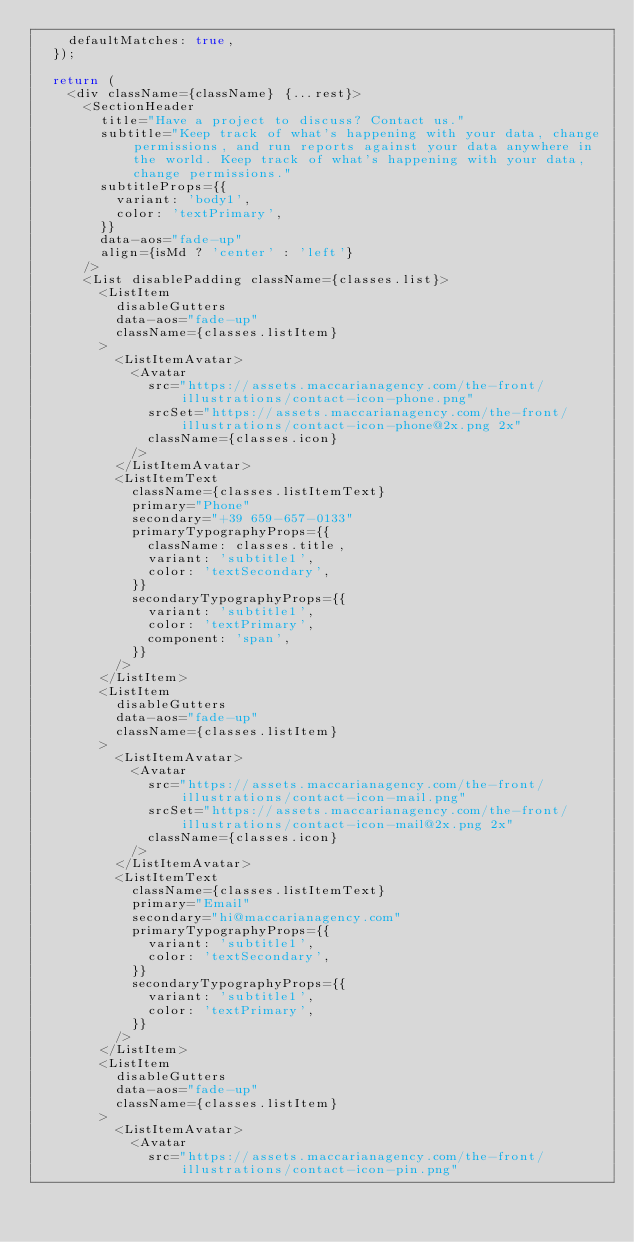<code> <loc_0><loc_0><loc_500><loc_500><_JavaScript_>    defaultMatches: true,
  });

  return (
    <div className={className} {...rest}>
      <SectionHeader
        title="Have a project to discuss? Contact us."
        subtitle="Keep track of what's happening with your data, change permissions, and run reports against your data anywhere in the world. Keep track of what's happening with your data, change permissions."
        subtitleProps={{
          variant: 'body1',
          color: 'textPrimary',
        }}
        data-aos="fade-up"
        align={isMd ? 'center' : 'left'}
      />
      <List disablePadding className={classes.list}>
        <ListItem
          disableGutters
          data-aos="fade-up"
          className={classes.listItem}
        >
          <ListItemAvatar>
            <Avatar
              src="https://assets.maccarianagency.com/the-front/illustrations/contact-icon-phone.png"
              srcSet="https://assets.maccarianagency.com/the-front/illustrations/contact-icon-phone@2x.png 2x"
              className={classes.icon}
            />
          </ListItemAvatar>
          <ListItemText
            className={classes.listItemText}
            primary="Phone"
            secondary="+39 659-657-0133"
            primaryTypographyProps={{
              className: classes.title,
              variant: 'subtitle1',
              color: 'textSecondary',
            }}
            secondaryTypographyProps={{
              variant: 'subtitle1',
              color: 'textPrimary',
              component: 'span',
            }}
          />
        </ListItem>
        <ListItem
          disableGutters
          data-aos="fade-up"
          className={classes.listItem}
        >
          <ListItemAvatar>
            <Avatar
              src="https://assets.maccarianagency.com/the-front/illustrations/contact-icon-mail.png"
              srcSet="https://assets.maccarianagency.com/the-front/illustrations/contact-icon-mail@2x.png 2x"
              className={classes.icon}
            />
          </ListItemAvatar>
          <ListItemText
            className={classes.listItemText}
            primary="Email"
            secondary="hi@maccarianagency.com"
            primaryTypographyProps={{
              variant: 'subtitle1',
              color: 'textSecondary',
            }}
            secondaryTypographyProps={{
              variant: 'subtitle1',
              color: 'textPrimary',
            }}
          />
        </ListItem>
        <ListItem
          disableGutters
          data-aos="fade-up"
          className={classes.listItem}
        >
          <ListItemAvatar>
            <Avatar
              src="https://assets.maccarianagency.com/the-front/illustrations/contact-icon-pin.png"</code> 